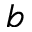<formula> <loc_0><loc_0><loc_500><loc_500>b</formula> 